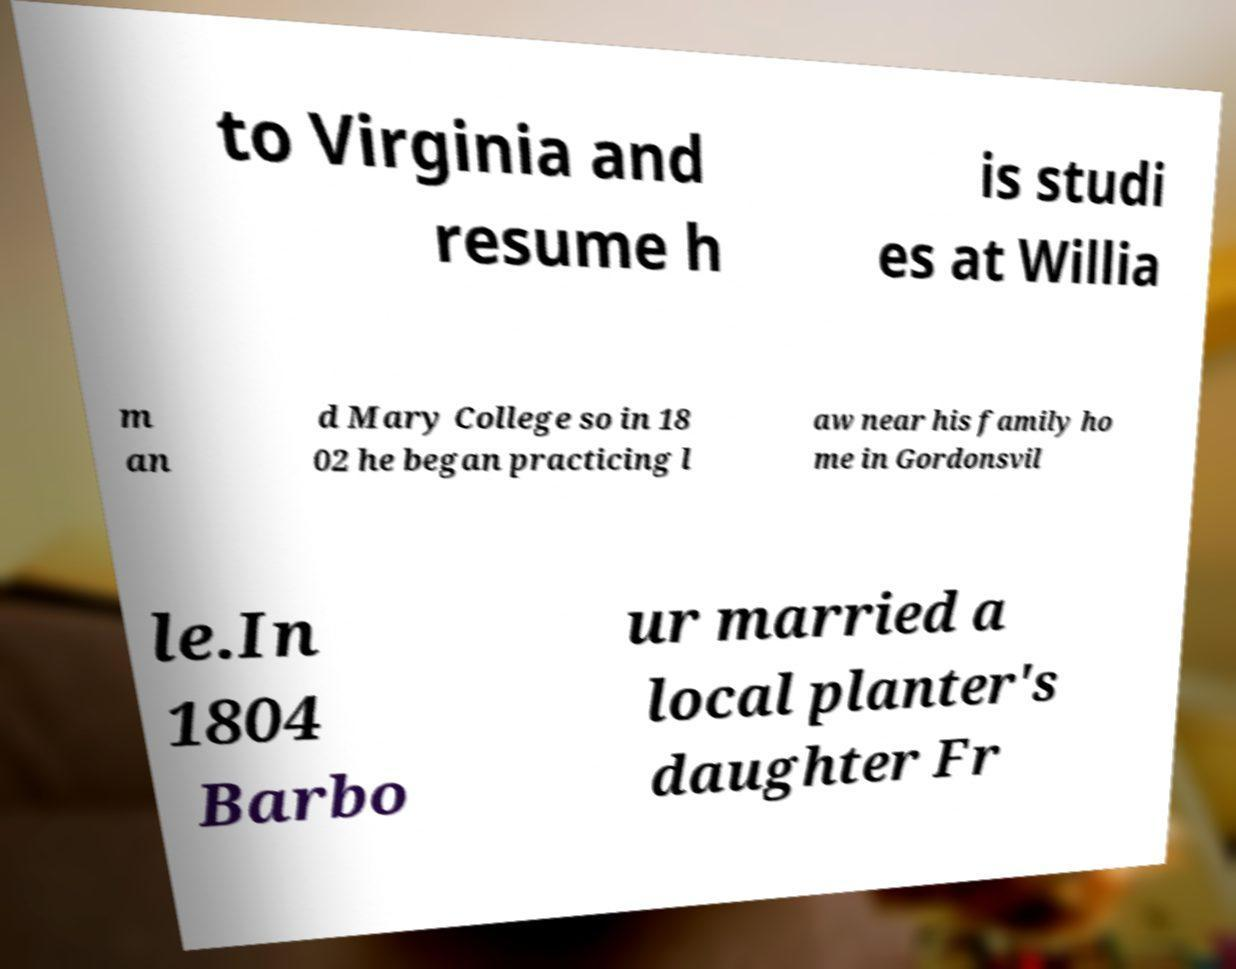Please read and relay the text visible in this image. What does it say? to Virginia and resume h is studi es at Willia m an d Mary College so in 18 02 he began practicing l aw near his family ho me in Gordonsvil le.In 1804 Barbo ur married a local planter's daughter Fr 